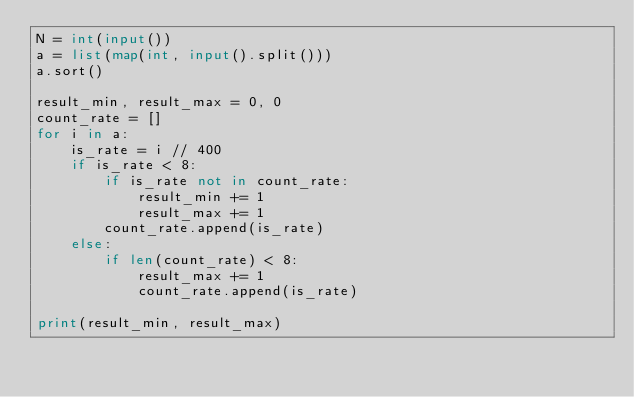Convert code to text. <code><loc_0><loc_0><loc_500><loc_500><_Python_>N = int(input())
a = list(map(int, input().split()))
a.sort()

result_min, result_max = 0, 0
count_rate = []
for i in a:
    is_rate = i // 400
    if is_rate < 8:
        if is_rate not in count_rate:
            result_min += 1
            result_max += 1
        count_rate.append(is_rate)
    else:
        if len(count_rate) < 8:
            result_max += 1
            count_rate.append(is_rate)

print(result_min, result_max)</code> 